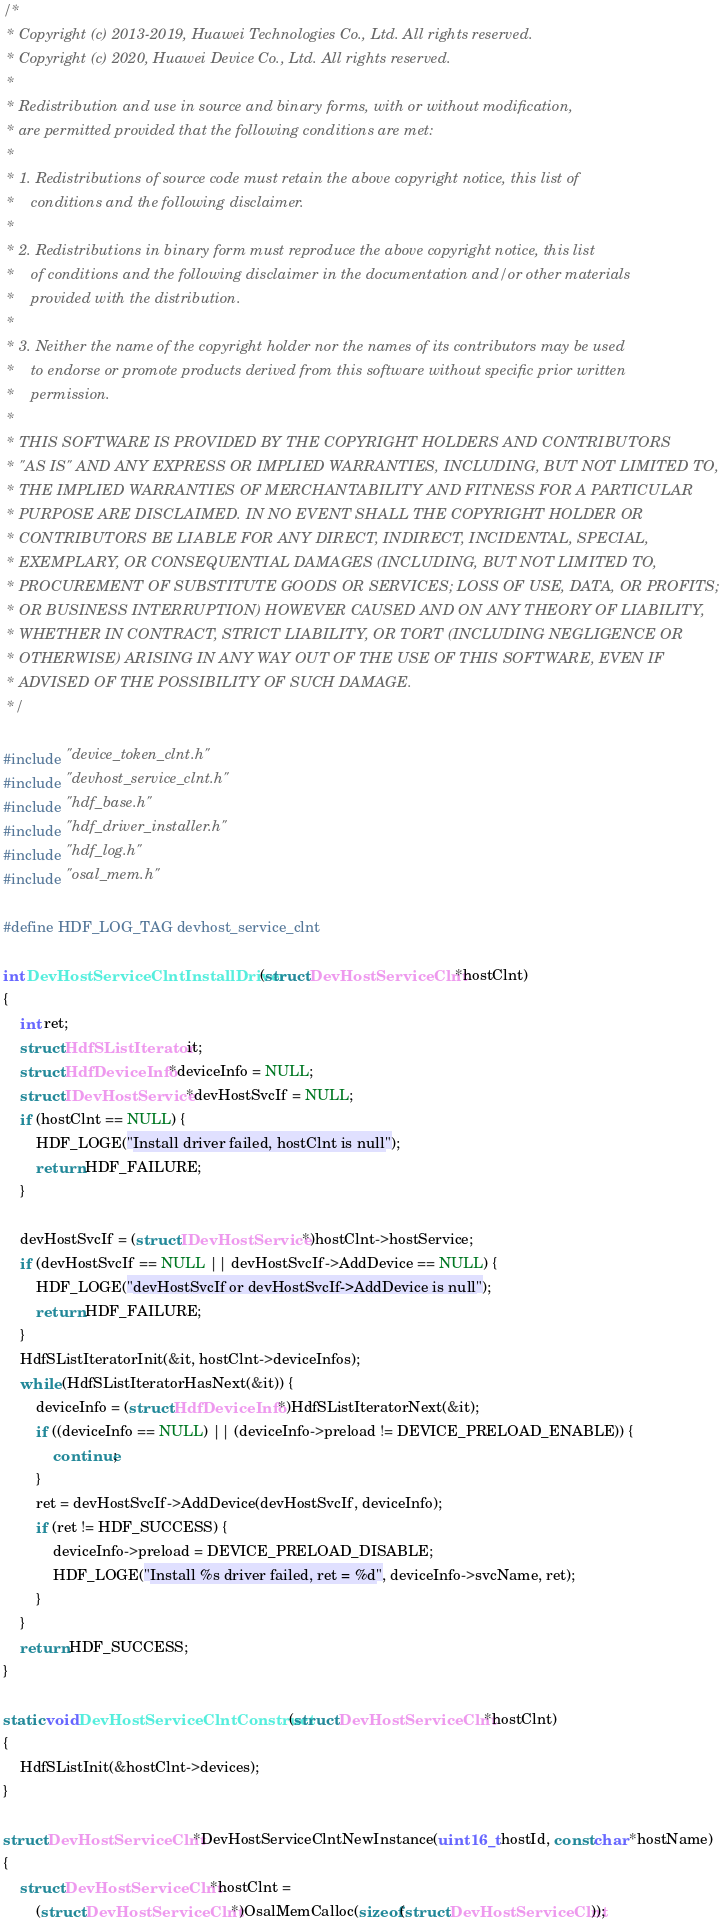<code> <loc_0><loc_0><loc_500><loc_500><_C_>/*
 * Copyright (c) 2013-2019, Huawei Technologies Co., Ltd. All rights reserved.
 * Copyright (c) 2020, Huawei Device Co., Ltd. All rights reserved.
 *
 * Redistribution and use in source and binary forms, with or without modification,
 * are permitted provided that the following conditions are met:
 *
 * 1. Redistributions of source code must retain the above copyright notice, this list of
 *    conditions and the following disclaimer.
 *
 * 2. Redistributions in binary form must reproduce the above copyright notice, this list
 *    of conditions and the following disclaimer in the documentation and/or other materials
 *    provided with the distribution.
 *
 * 3. Neither the name of the copyright holder nor the names of its contributors may be used
 *    to endorse or promote products derived from this software without specific prior written
 *    permission.
 *
 * THIS SOFTWARE IS PROVIDED BY THE COPYRIGHT HOLDERS AND CONTRIBUTORS
 * "AS IS" AND ANY EXPRESS OR IMPLIED WARRANTIES, INCLUDING, BUT NOT LIMITED TO,
 * THE IMPLIED WARRANTIES OF MERCHANTABILITY AND FITNESS FOR A PARTICULAR
 * PURPOSE ARE DISCLAIMED. IN NO EVENT SHALL THE COPYRIGHT HOLDER OR
 * CONTRIBUTORS BE LIABLE FOR ANY DIRECT, INDIRECT, INCIDENTAL, SPECIAL,
 * EXEMPLARY, OR CONSEQUENTIAL DAMAGES (INCLUDING, BUT NOT LIMITED TO,
 * PROCUREMENT OF SUBSTITUTE GOODS OR SERVICES; LOSS OF USE, DATA, OR PROFITS;
 * OR BUSINESS INTERRUPTION) HOWEVER CAUSED AND ON ANY THEORY OF LIABILITY,
 * WHETHER IN CONTRACT, STRICT LIABILITY, OR TORT (INCLUDING NEGLIGENCE OR
 * OTHERWISE) ARISING IN ANY WAY OUT OF THE USE OF THIS SOFTWARE, EVEN IF
 * ADVISED OF THE POSSIBILITY OF SUCH DAMAGE.
 */

#include "device_token_clnt.h"
#include "devhost_service_clnt.h"
#include "hdf_base.h"
#include "hdf_driver_installer.h"
#include "hdf_log.h"
#include "osal_mem.h"

#define HDF_LOG_TAG devhost_service_clnt

int DevHostServiceClntInstallDriver(struct DevHostServiceClnt *hostClnt)
{
    int ret;
    struct HdfSListIterator it;
    struct HdfDeviceInfo *deviceInfo = NULL;
    struct IDevHostService *devHostSvcIf = NULL;
    if (hostClnt == NULL) {
        HDF_LOGE("Install driver failed, hostClnt is null");
        return HDF_FAILURE;
    }

    devHostSvcIf = (struct IDevHostService *)hostClnt->hostService;
    if (devHostSvcIf == NULL || devHostSvcIf->AddDevice == NULL) {
        HDF_LOGE("devHostSvcIf or devHostSvcIf->AddDevice is null");
        return HDF_FAILURE;
    }
    HdfSListIteratorInit(&it, hostClnt->deviceInfos);
    while (HdfSListIteratorHasNext(&it)) {
        deviceInfo = (struct HdfDeviceInfo *)HdfSListIteratorNext(&it);
        if ((deviceInfo == NULL) || (deviceInfo->preload != DEVICE_PRELOAD_ENABLE)) {
            continue;
        }
        ret = devHostSvcIf->AddDevice(devHostSvcIf, deviceInfo);
        if (ret != HDF_SUCCESS) {
            deviceInfo->preload = DEVICE_PRELOAD_DISABLE;
            HDF_LOGE("Install %s driver failed, ret = %d", deviceInfo->svcName, ret);
        }
    }
    return HDF_SUCCESS;
}

static void DevHostServiceClntConstruct(struct DevHostServiceClnt *hostClnt)
{
    HdfSListInit(&hostClnt->devices);
}

struct DevHostServiceClnt *DevHostServiceClntNewInstance(uint16_t hostId, const char *hostName)
{
    struct DevHostServiceClnt *hostClnt =
        (struct DevHostServiceClnt *)OsalMemCalloc(sizeof(struct DevHostServiceClnt));</code> 